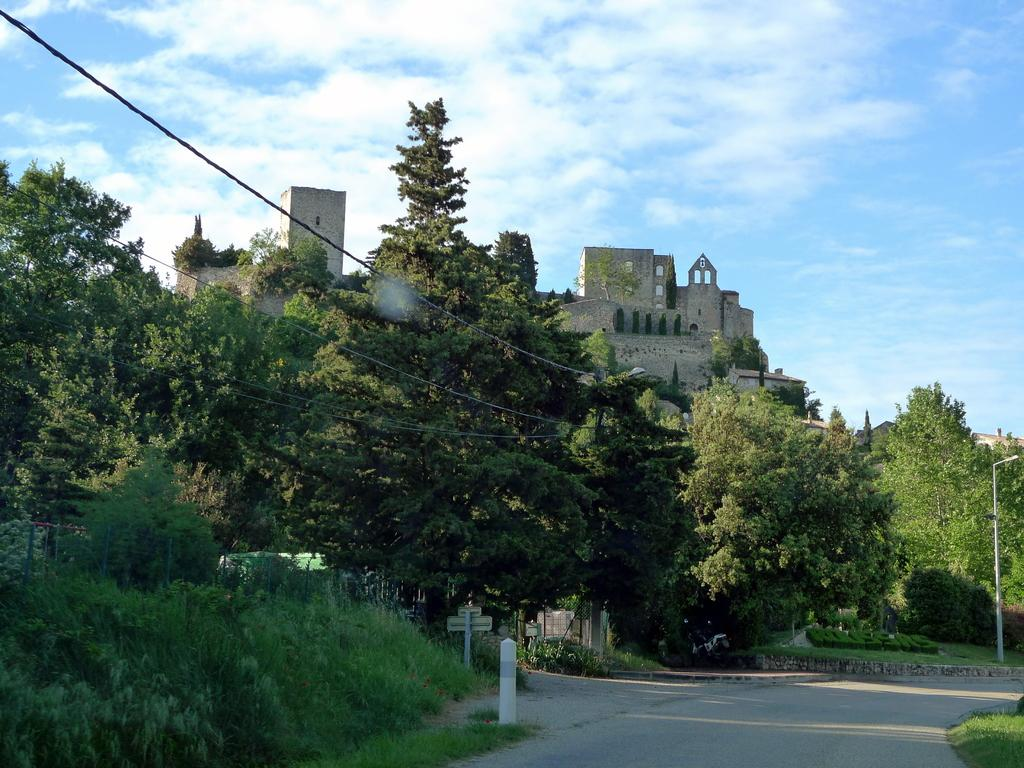What type of surface can be seen in the image? There is a road in the image. What structures are present alongside the road? There are poles and a fort in the image. What type of vegetation is visible in the image? There are trees and grass in the image. What else can be seen in the image besides the road and vegetation? There are wires in the image. What is visible in the background of the image? The sky is visible in the background of the image, and there are clouds in the sky. What type of fuel is being used by the island in the image? There is no island present in the image, so the question about fuel cannot be answered. Who is the partner of the person standing next to the fort in the image? There is no person standing next to the fort in the image, so the question about a partner cannot be answered. 